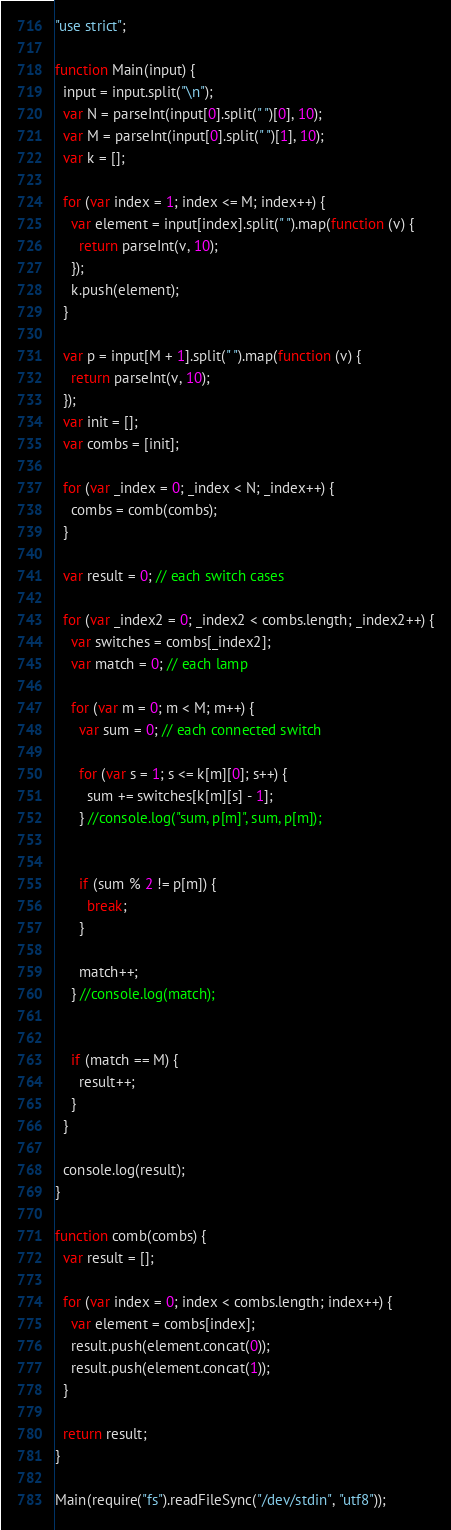<code> <loc_0><loc_0><loc_500><loc_500><_JavaScript_>"use strict";

function Main(input) {
  input = input.split("\n");
  var N = parseInt(input[0].split(" ")[0], 10);
  var M = parseInt(input[0].split(" ")[1], 10);
  var k = [];

  for (var index = 1; index <= M; index++) {
    var element = input[index].split(" ").map(function (v) {
      return parseInt(v, 10);
    });
    k.push(element);
  }

  var p = input[M + 1].split(" ").map(function (v) {
    return parseInt(v, 10);
  });
  var init = [];
  var combs = [init];

  for (var _index = 0; _index < N; _index++) {
    combs = comb(combs);
  }

  var result = 0; // each switch cases

  for (var _index2 = 0; _index2 < combs.length; _index2++) {
    var switches = combs[_index2];
    var match = 0; // each lamp        

    for (var m = 0; m < M; m++) {
      var sum = 0; // each connected switch

      for (var s = 1; s <= k[m][0]; s++) {
        sum += switches[k[m][s] - 1];
      } //console.log("sum, p[m]", sum, p[m]);


      if (sum % 2 != p[m]) {
        break;
      }

      match++;
    } //console.log(match);


    if (match == M) {
      result++;
    }
  }

  console.log(result);
}

function comb(combs) {
  var result = [];

  for (var index = 0; index < combs.length; index++) {
    var element = combs[index];
    result.push(element.concat(0));
    result.push(element.concat(1));
  }

  return result;
}

Main(require("fs").readFileSync("/dev/stdin", "utf8"));</code> 